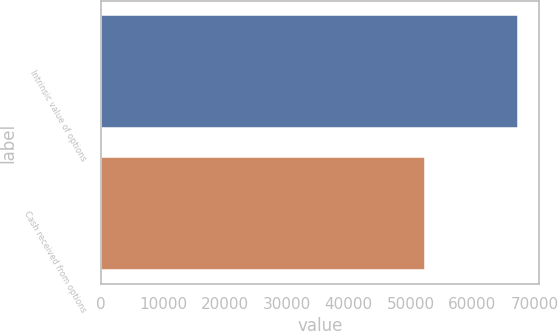Convert chart to OTSL. <chart><loc_0><loc_0><loc_500><loc_500><bar_chart><fcel>Intrinsic value of options<fcel>Cash received from options<nl><fcel>67363<fcel>52261<nl></chart> 